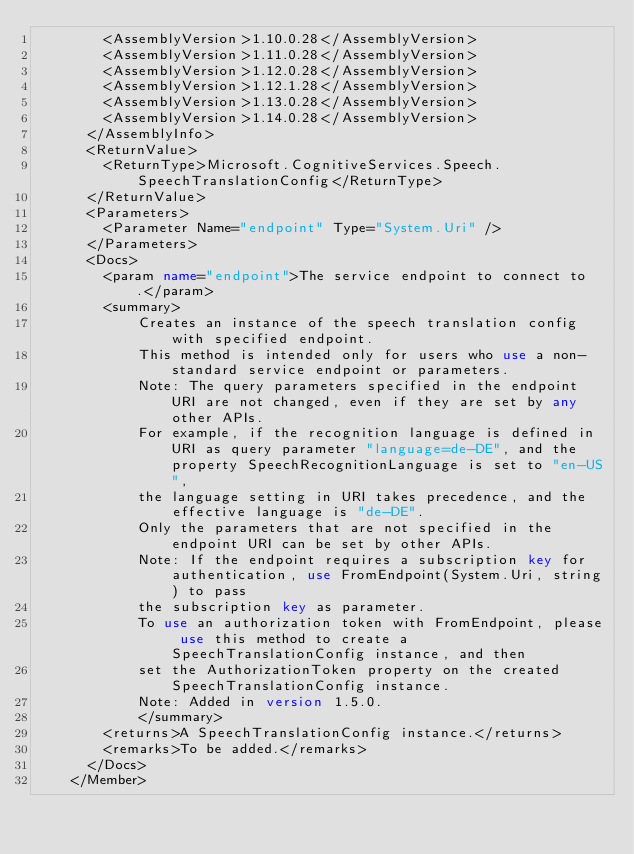Convert code to text. <code><loc_0><loc_0><loc_500><loc_500><_XML_>        <AssemblyVersion>1.10.0.28</AssemblyVersion>
        <AssemblyVersion>1.11.0.28</AssemblyVersion>
        <AssemblyVersion>1.12.0.28</AssemblyVersion>
        <AssemblyVersion>1.12.1.28</AssemblyVersion>
        <AssemblyVersion>1.13.0.28</AssemblyVersion>
        <AssemblyVersion>1.14.0.28</AssemblyVersion>
      </AssemblyInfo>
      <ReturnValue>
        <ReturnType>Microsoft.CognitiveServices.Speech.SpeechTranslationConfig</ReturnType>
      </ReturnValue>
      <Parameters>
        <Parameter Name="endpoint" Type="System.Uri" />
      </Parameters>
      <Docs>
        <param name="endpoint">The service endpoint to connect to.</param>
        <summary>
            Creates an instance of the speech translation config with specified endpoint.
            This method is intended only for users who use a non-standard service endpoint or parameters.
            Note: The query parameters specified in the endpoint URI are not changed, even if they are set by any other APIs.
            For example, if the recognition language is defined in URI as query parameter "language=de-DE", and the property SpeechRecognitionLanguage is set to "en-US",
            the language setting in URI takes precedence, and the effective language is "de-DE".
            Only the parameters that are not specified in the endpoint URI can be set by other APIs.
            Note: If the endpoint requires a subscription key for authentication, use FromEndpoint(System.Uri, string) to pass
            the subscription key as parameter.
            To use an authorization token with FromEndpoint, please use this method to create a SpeechTranslationConfig instance, and then
            set the AuthorizationToken property on the created SpeechTranslationConfig instance.
            Note: Added in version 1.5.0.
            </summary>
        <returns>A SpeechTranslationConfig instance.</returns>
        <remarks>To be added.</remarks>
      </Docs>
    </Member></code> 